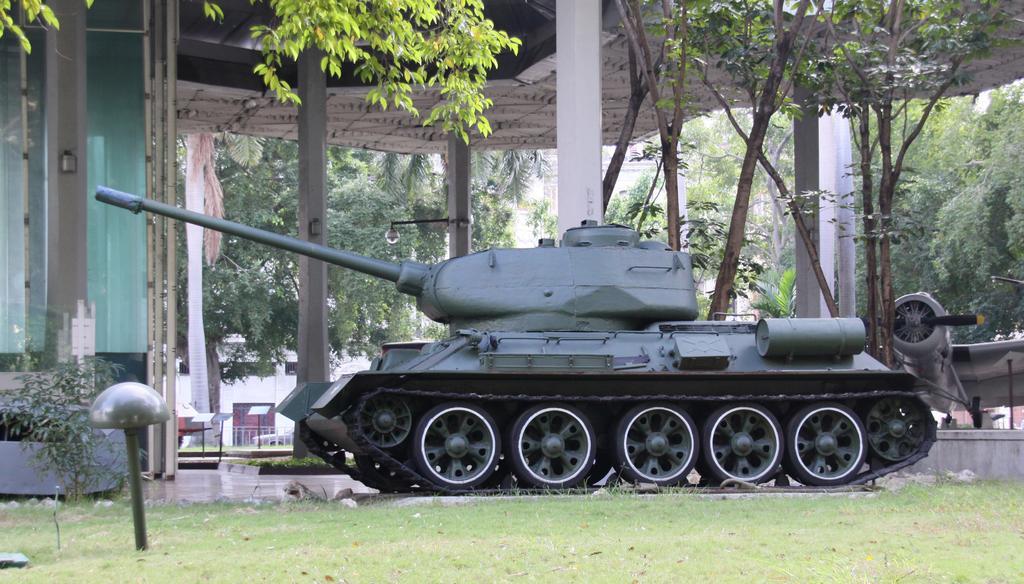Please provide a concise description of this image. Land is covered with grass. Here we can see military vehicle and plane. Background there are trees, open-shed, pillars, light, information boards and plants. This is glass wall. 